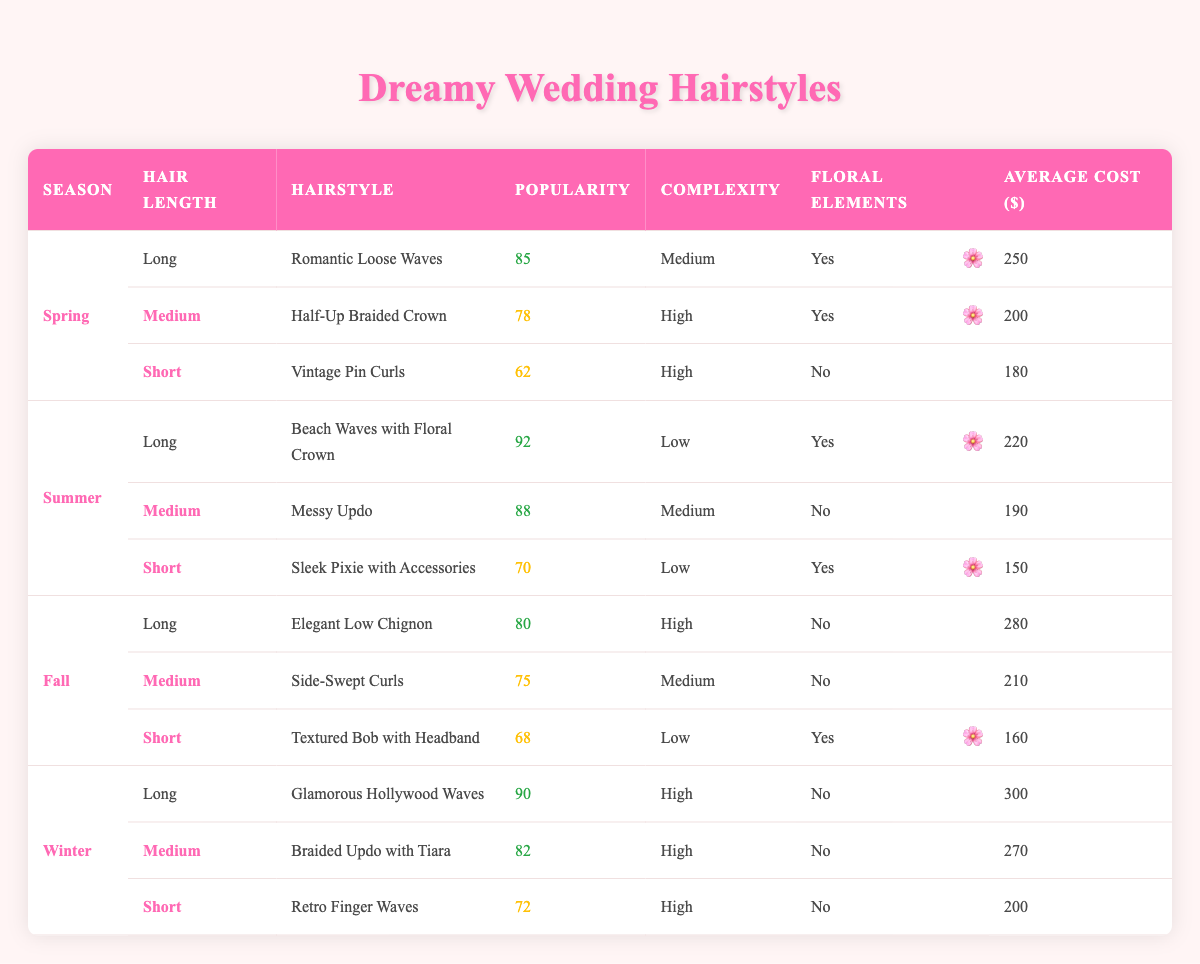What is the most popular hairstyle for long hair in the summer? The table shows that the most popular hairstyle for long hair in the summer is "Beach Waves with Floral Crown" with a popularity score of 92.
Answer: Beach Waves with Floral Crown Which hairstyle has the highest average cost across all seasons? By examining the average costs listed in the table, "Glamorous Hollywood Waves" has the highest cost at $300.
Answer: Glamorous Hollywood Waves How many hairstyles in the spring have floral elements? In the spring, there are two hairstyles that have floral elements: "Romantic Loose Waves" and "Half-Up Braided Crown." Therefore, the answer is two.
Answer: Two What is the average popularity score of medium length hairstyles? To find the average, sum the popularity scores of the medium hairstyles: 78 (Spring) + 88 (Summer) + 75 (Fall) + 82 (Winter) = 323. There are 4 medium hairstyles, so averaging gives 323 / 4 = 80.75.
Answer: 80.75 Is there a hairstyle for short hair in the spring that includes floral elements? Looking at the spring season, the short hair option "Vintage Pin Curls" does not include floral elements, so the answer is no.
Answer: No Which season features the most hairstyles rated with high complexity? In the table, spring, summer, fall, and winter all feature hairstyles with high complexity, but spring has two high complexity hairstyles (Half-Up Braided Crown and Vintage Pin Curls). Summer has one (Messy Updo), fall has one (Elegant Low Chignon), and winter has three (Glamorous Hollywood Waves, Braided Updo with Tiara, and Retro Finger Waves). Therefore, winter features the most hairstyles rated with high complexity.
Answer: Winter What is the cost difference between the most expensive and the least expensive hairstyles in the table? The most expensive hairstyle is "Glamorous Hollywood Waves" ($300), and the least expensive is "Sleek Pixie with Accessories" ($150). The cost difference is $300 - $150 = $150.
Answer: 150 Which hairstyle is popular for short hair in the summer? The table indicates that for short hair in the summer, the hairstyle is "Sleek Pixie with Accessories," which has a popularity score of 70.
Answer: Sleek Pixie with Accessories 